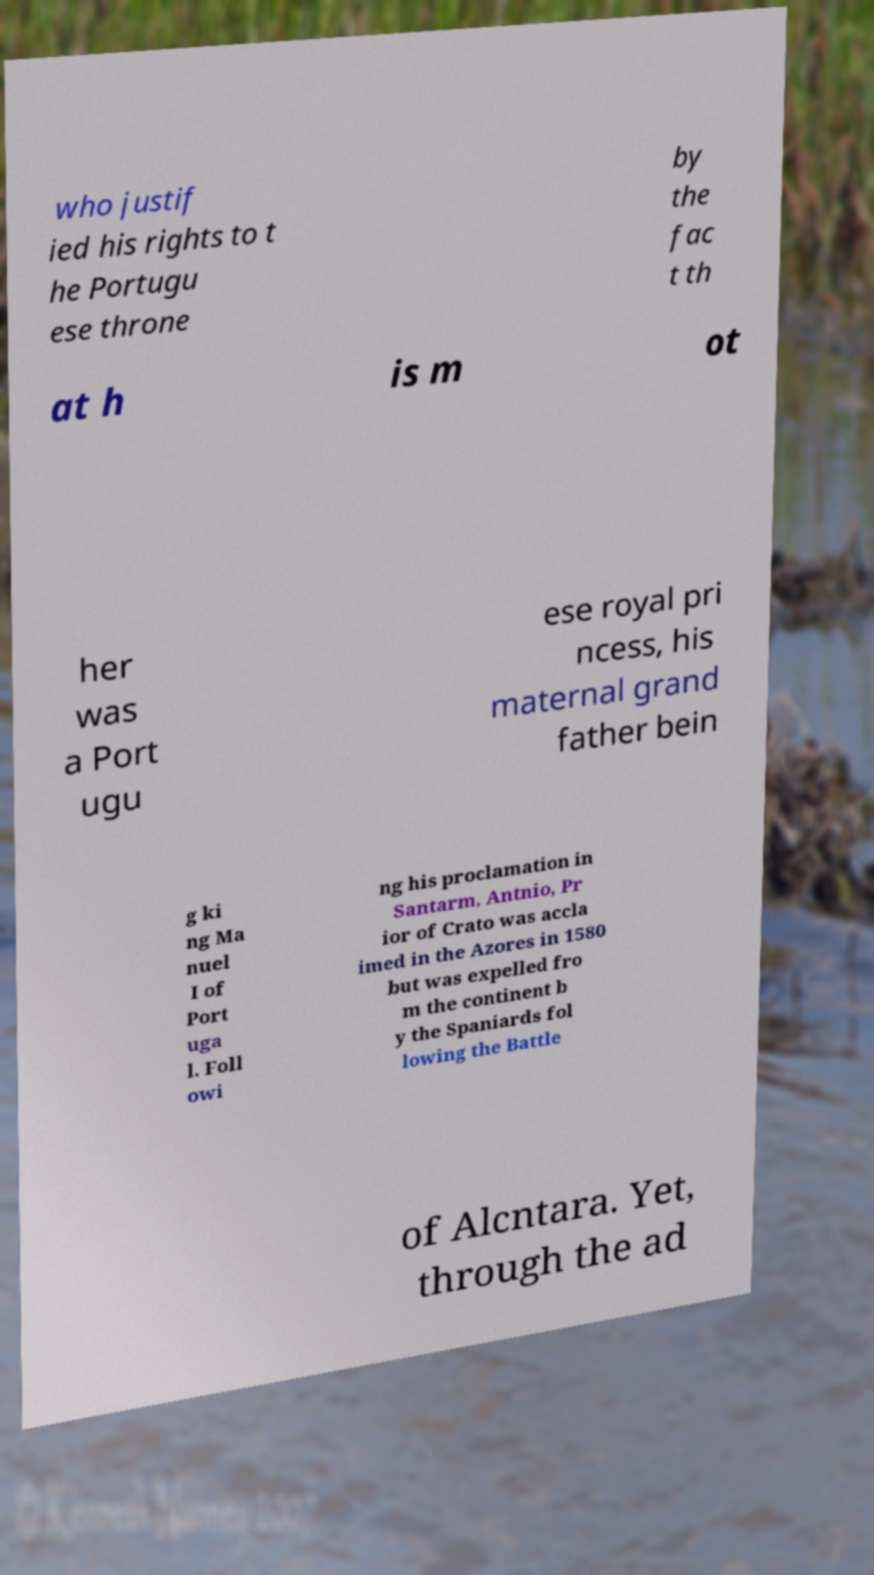For documentation purposes, I need the text within this image transcribed. Could you provide that? who justif ied his rights to t he Portugu ese throne by the fac t th at h is m ot her was a Port ugu ese royal pri ncess, his maternal grand father bein g ki ng Ma nuel I of Port uga l. Foll owi ng his proclamation in Santarm, Antnio, Pr ior of Crato was accla imed in the Azores in 1580 but was expelled fro m the continent b y the Spaniards fol lowing the Battle of Alcntara. Yet, through the ad 